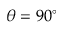<formula> <loc_0><loc_0><loc_500><loc_500>\theta = 9 0 ^ { \circ }</formula> 